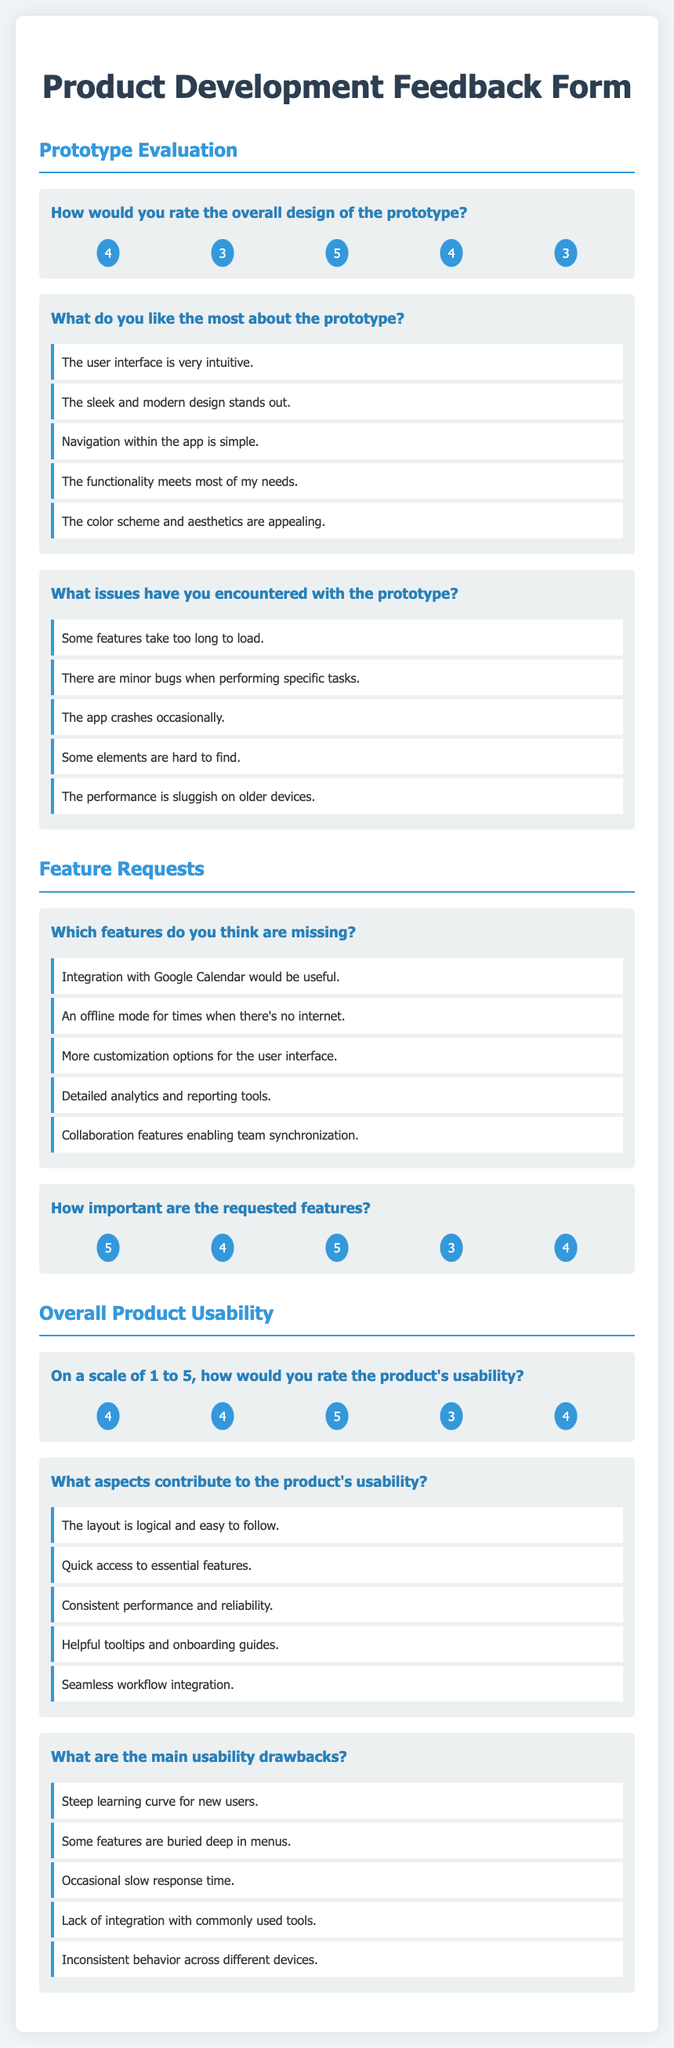How would you rate the overall design of the prototype? The document provides feedback on the design rating given by users, which includes scores.
Answer: 4 What elements are disliked in the prototype? The document outlines issues encountered by users regarding the prototype, highlighting specific problems.
Answer: Some features take too long to load Which feature was requested the most? The document lists features users found missing and highlights integration, offline capabilities, and analytics as key requests.
Answer: Integration with Google Calendar would be useful What is the average rating for the product's usability? The document contains user ratings for usability, which can be averaged for a summary.
Answer: 4 What contributes to the product's usability? The document describes positive aspects that enhance the usability of the product as described by users.
Answer: The layout is logical and easy to follow What is the main usability drawback according to users? Users provide feedback on usability drawbacks in the document, detailing specific challenges they faced.
Answer: Steep learning curve for new users How many users mentioned that the app crashes occasionally? The document lists user feedback, including complaints about crashes, indicating the frequency of this issue.
Answer: Not specifically mentioned What rating did the highest number of users give for the importance of requested features? The document includes ratings on the importance of new features, revealing which rating was most common.
Answer: 5 